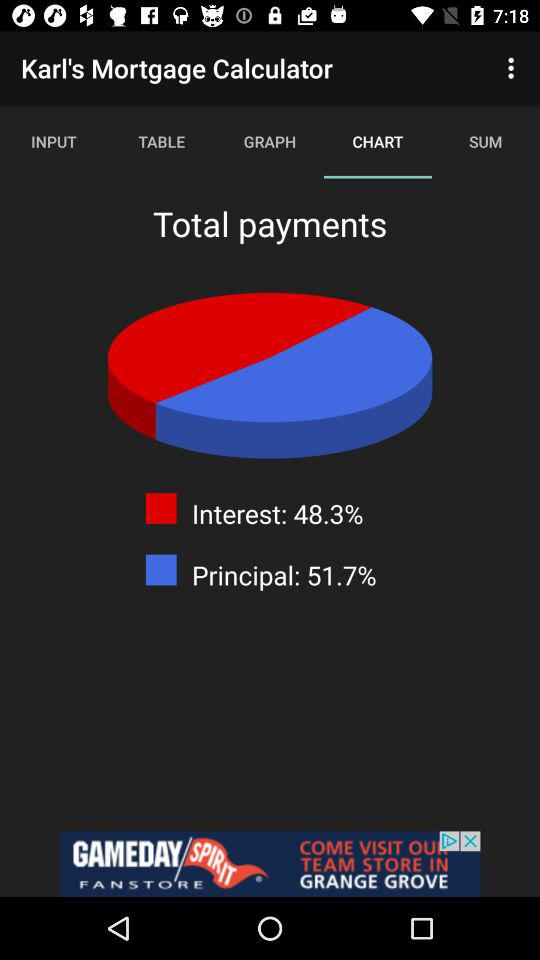Which tab is selected? The selected tab is "CHART". 